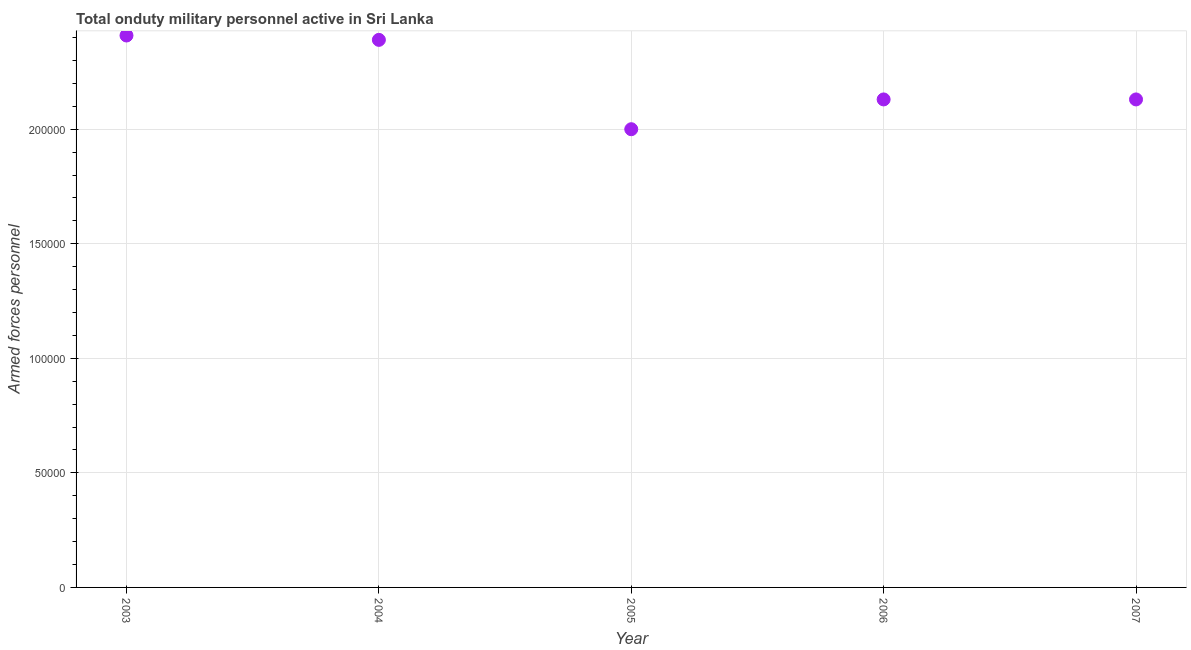What is the number of armed forces personnel in 2003?
Provide a short and direct response. 2.41e+05. Across all years, what is the maximum number of armed forces personnel?
Offer a terse response. 2.41e+05. Across all years, what is the minimum number of armed forces personnel?
Your answer should be very brief. 2.00e+05. In which year was the number of armed forces personnel maximum?
Your answer should be very brief. 2003. What is the sum of the number of armed forces personnel?
Keep it short and to the point. 1.11e+06. What is the difference between the number of armed forces personnel in 2004 and 2005?
Ensure brevity in your answer.  3.90e+04. What is the average number of armed forces personnel per year?
Offer a very short reply. 2.21e+05. What is the median number of armed forces personnel?
Your response must be concise. 2.13e+05. In how many years, is the number of armed forces personnel greater than 120000 ?
Make the answer very short. 5. Do a majority of the years between 2007 and 2004 (inclusive) have number of armed forces personnel greater than 90000 ?
Ensure brevity in your answer.  Yes. What is the ratio of the number of armed forces personnel in 2005 to that in 2006?
Offer a very short reply. 0.94. Is the number of armed forces personnel in 2006 less than that in 2007?
Your answer should be very brief. No. Is the difference between the number of armed forces personnel in 2003 and 2004 greater than the difference between any two years?
Your answer should be very brief. No. What is the difference between the highest and the second highest number of armed forces personnel?
Give a very brief answer. 1900. Is the sum of the number of armed forces personnel in 2003 and 2005 greater than the maximum number of armed forces personnel across all years?
Offer a very short reply. Yes. What is the difference between the highest and the lowest number of armed forces personnel?
Your answer should be very brief. 4.09e+04. Does the number of armed forces personnel monotonically increase over the years?
Your answer should be compact. No. How many dotlines are there?
Give a very brief answer. 1. How many years are there in the graph?
Ensure brevity in your answer.  5. Does the graph contain grids?
Offer a very short reply. Yes. What is the title of the graph?
Give a very brief answer. Total onduty military personnel active in Sri Lanka. What is the label or title of the X-axis?
Your response must be concise. Year. What is the label or title of the Y-axis?
Offer a very short reply. Armed forces personnel. What is the Armed forces personnel in 2003?
Give a very brief answer. 2.41e+05. What is the Armed forces personnel in 2004?
Provide a short and direct response. 2.39e+05. What is the Armed forces personnel in 2006?
Provide a short and direct response. 2.13e+05. What is the Armed forces personnel in 2007?
Give a very brief answer. 2.13e+05. What is the difference between the Armed forces personnel in 2003 and 2004?
Your response must be concise. 1900. What is the difference between the Armed forces personnel in 2003 and 2005?
Make the answer very short. 4.09e+04. What is the difference between the Armed forces personnel in 2003 and 2006?
Make the answer very short. 2.79e+04. What is the difference between the Armed forces personnel in 2003 and 2007?
Your answer should be compact. 2.79e+04. What is the difference between the Armed forces personnel in 2004 and 2005?
Offer a terse response. 3.90e+04. What is the difference between the Armed forces personnel in 2004 and 2006?
Your answer should be compact. 2.60e+04. What is the difference between the Armed forces personnel in 2004 and 2007?
Offer a terse response. 2.60e+04. What is the difference between the Armed forces personnel in 2005 and 2006?
Offer a very short reply. -1.30e+04. What is the difference between the Armed forces personnel in 2005 and 2007?
Offer a very short reply. -1.30e+04. What is the ratio of the Armed forces personnel in 2003 to that in 2005?
Your answer should be very brief. 1.2. What is the ratio of the Armed forces personnel in 2003 to that in 2006?
Your answer should be very brief. 1.13. What is the ratio of the Armed forces personnel in 2003 to that in 2007?
Provide a succinct answer. 1.13. What is the ratio of the Armed forces personnel in 2004 to that in 2005?
Give a very brief answer. 1.2. What is the ratio of the Armed forces personnel in 2004 to that in 2006?
Your answer should be very brief. 1.12. What is the ratio of the Armed forces personnel in 2004 to that in 2007?
Provide a succinct answer. 1.12. What is the ratio of the Armed forces personnel in 2005 to that in 2006?
Provide a short and direct response. 0.94. What is the ratio of the Armed forces personnel in 2005 to that in 2007?
Give a very brief answer. 0.94. What is the ratio of the Armed forces personnel in 2006 to that in 2007?
Ensure brevity in your answer.  1. 